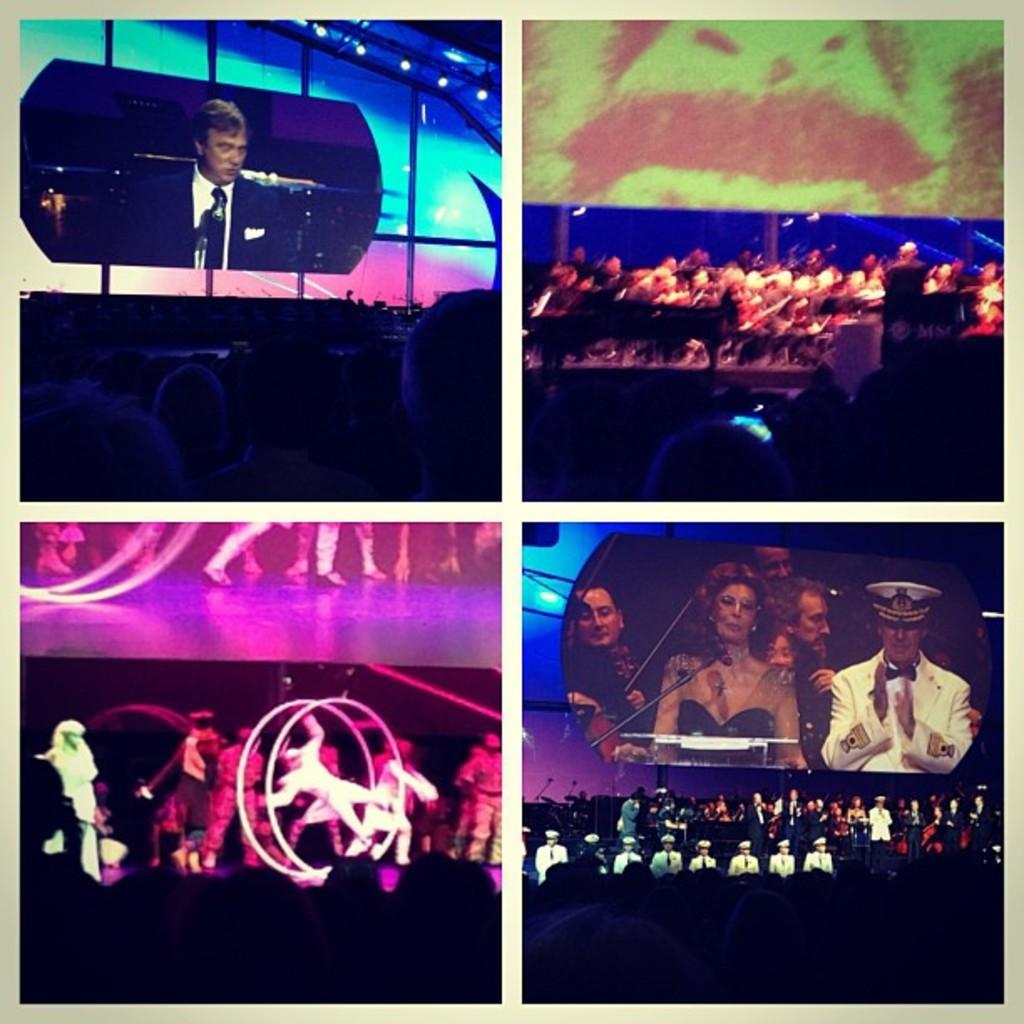What type of image is being described? The image is a collage. What can be seen on the collage? There is a screen, a person talking on a microphone, people on a stage, a crowd, and people visible on the screen. What is the person with the microphone doing? The person is talking on a microphone. Where are the people on the stage? The people are on a stage in the image. What is the purpose of the screen in the image? The screen is displaying people, which suggests it might be used for showing a live feed or presentation. What type of drain is visible in the image? There is no drain present in the image. How does the sock help the person on stage? There is no sock mentioned in the image, so it cannot be determined how it might help the person on stage. 